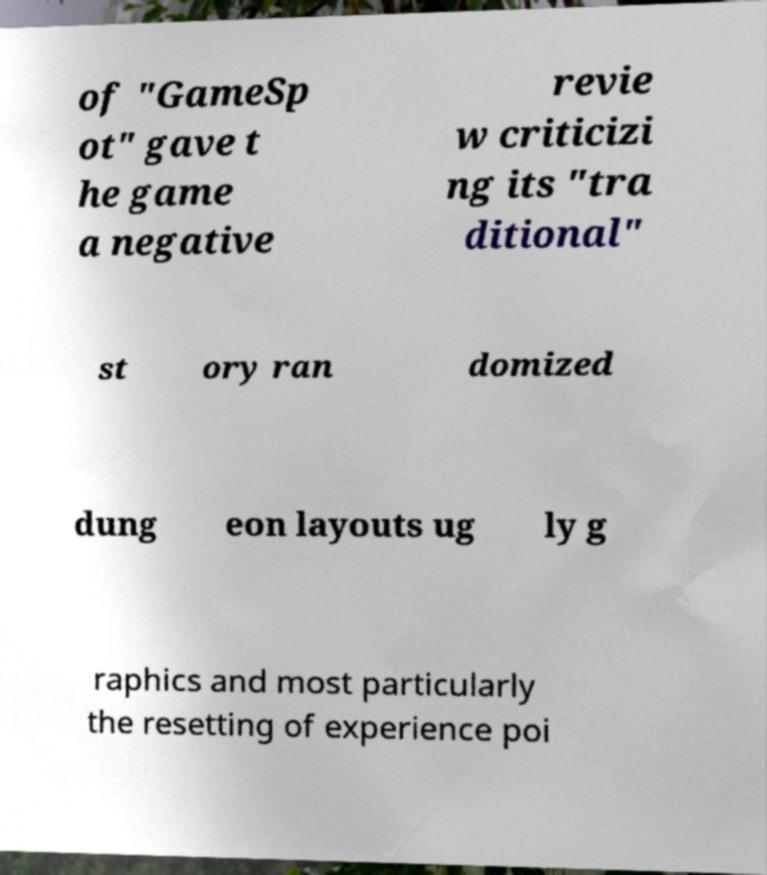Please read and relay the text visible in this image. What does it say? of "GameSp ot" gave t he game a negative revie w criticizi ng its "tra ditional" st ory ran domized dung eon layouts ug ly g raphics and most particularly the resetting of experience poi 